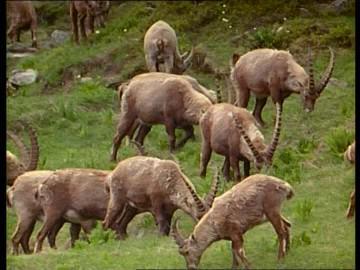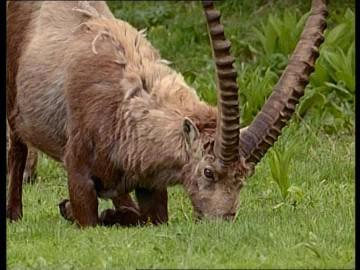The first image is the image on the left, the second image is the image on the right. Assess this claim about the two images: "One of the images contains a single animal.". Correct or not? Answer yes or no. Yes. The first image is the image on the left, the second image is the image on the right. Considering the images on both sides, is "the image on the lft contains a single antelope" valid? Answer yes or no. No. 